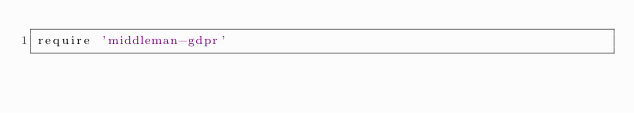Convert code to text. <code><loc_0><loc_0><loc_500><loc_500><_Ruby_>require 'middleman-gdpr'
</code> 